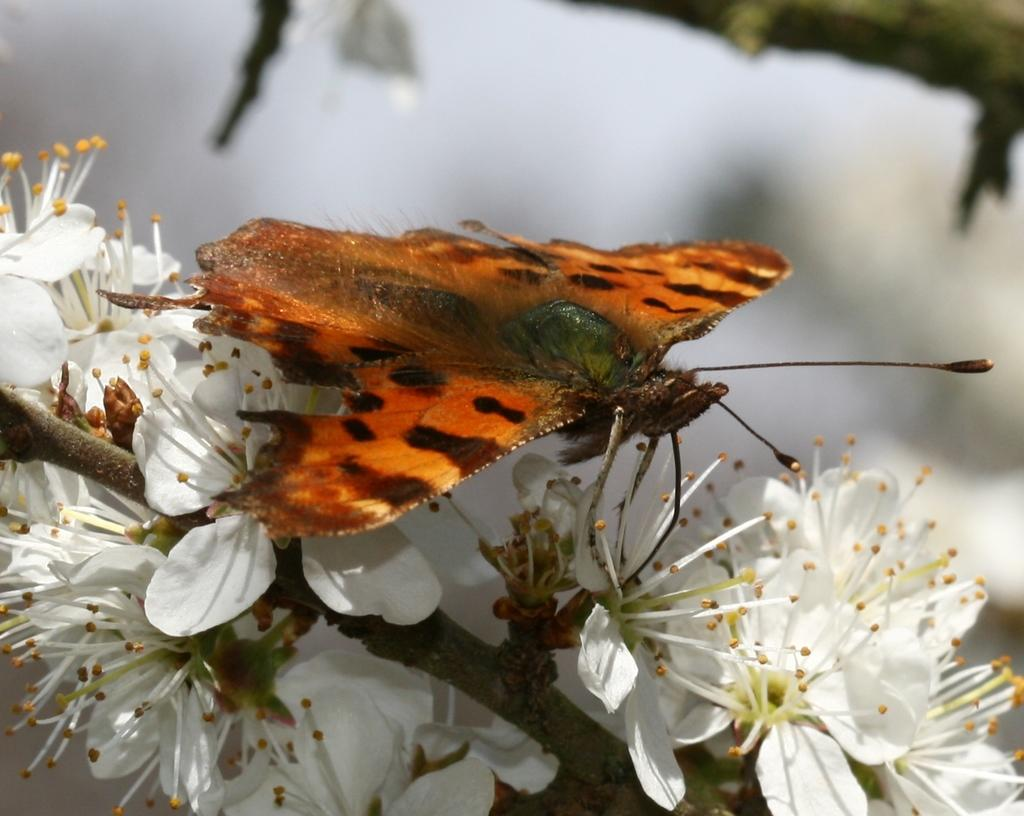What type of creature can be seen in the image? There is a butterfly in the image. What other elements are present in the image besides the butterfly? There are flowers and a branch in the image. Can you describe the background of the image? The background of the image is blurry. What time of day is depicted in the image? The provided facts do not mention the time of day, so it cannot be determined from the image. 